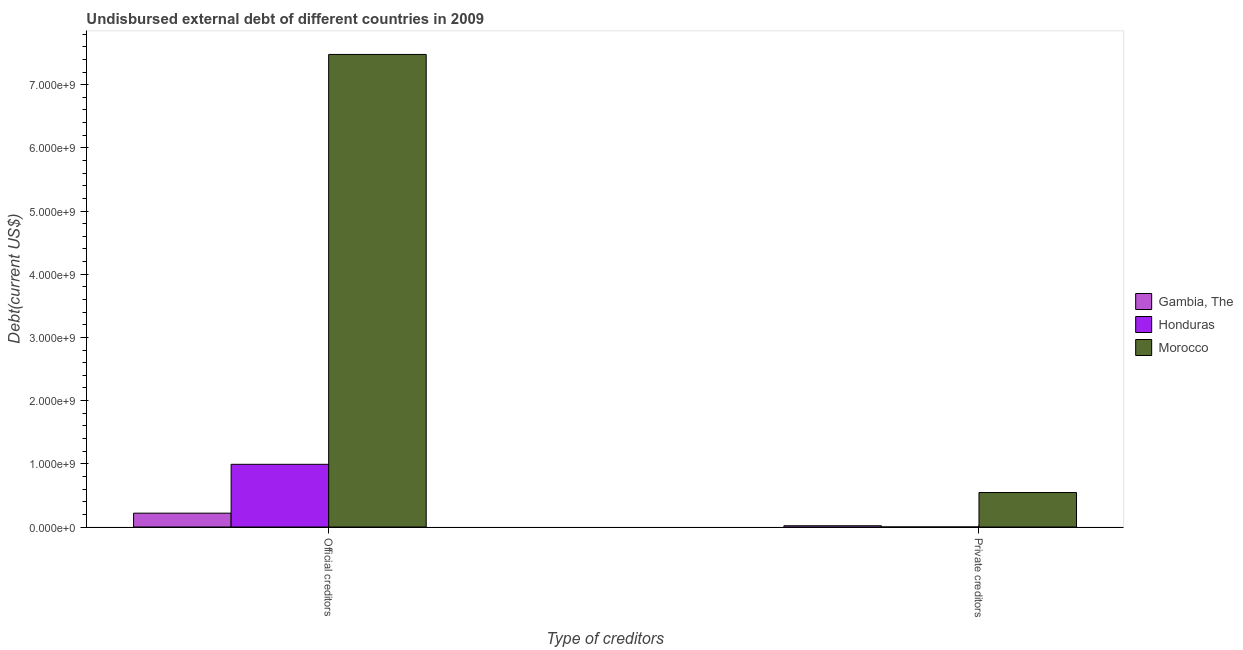How many bars are there on the 1st tick from the left?
Ensure brevity in your answer.  3. How many bars are there on the 2nd tick from the right?
Give a very brief answer. 3. What is the label of the 1st group of bars from the left?
Ensure brevity in your answer.  Official creditors. What is the undisbursed external debt of official creditors in Honduras?
Make the answer very short. 9.92e+08. Across all countries, what is the maximum undisbursed external debt of private creditors?
Keep it short and to the point. 5.46e+08. Across all countries, what is the minimum undisbursed external debt of official creditors?
Your response must be concise. 2.19e+08. In which country was the undisbursed external debt of official creditors maximum?
Ensure brevity in your answer.  Morocco. In which country was the undisbursed external debt of official creditors minimum?
Your answer should be very brief. Gambia, The. What is the total undisbursed external debt of official creditors in the graph?
Offer a very short reply. 8.69e+09. What is the difference between the undisbursed external debt of private creditors in Gambia, The and that in Morocco?
Make the answer very short. -5.26e+08. What is the difference between the undisbursed external debt of private creditors in Gambia, The and the undisbursed external debt of official creditors in Honduras?
Your answer should be very brief. -9.72e+08. What is the average undisbursed external debt of private creditors per country?
Offer a terse response. 1.89e+08. What is the difference between the undisbursed external debt of official creditors and undisbursed external debt of private creditors in Morocco?
Your answer should be compact. 6.93e+09. In how many countries, is the undisbursed external debt of official creditors greater than 4000000000 US$?
Make the answer very short. 1. What is the ratio of the undisbursed external debt of private creditors in Honduras to that in Morocco?
Your response must be concise. 0. In how many countries, is the undisbursed external debt of official creditors greater than the average undisbursed external debt of official creditors taken over all countries?
Offer a very short reply. 1. What does the 1st bar from the left in Official creditors represents?
Provide a succinct answer. Gambia, The. What does the 3rd bar from the right in Official creditors represents?
Offer a very short reply. Gambia, The. Are all the bars in the graph horizontal?
Your response must be concise. No. Does the graph contain any zero values?
Your answer should be very brief. No. Does the graph contain grids?
Offer a terse response. No. How are the legend labels stacked?
Your response must be concise. Vertical. What is the title of the graph?
Provide a succinct answer. Undisbursed external debt of different countries in 2009. What is the label or title of the X-axis?
Give a very brief answer. Type of creditors. What is the label or title of the Y-axis?
Offer a very short reply. Debt(current US$). What is the Debt(current US$) of Gambia, The in Official creditors?
Offer a terse response. 2.19e+08. What is the Debt(current US$) in Honduras in Official creditors?
Your response must be concise. 9.92e+08. What is the Debt(current US$) in Morocco in Official creditors?
Make the answer very short. 7.48e+09. What is the Debt(current US$) of Gambia, The in Private creditors?
Give a very brief answer. 2.00e+07. What is the Debt(current US$) in Honduras in Private creditors?
Your response must be concise. 1.32e+05. What is the Debt(current US$) in Morocco in Private creditors?
Give a very brief answer. 5.46e+08. Across all Type of creditors, what is the maximum Debt(current US$) of Gambia, The?
Your answer should be compact. 2.19e+08. Across all Type of creditors, what is the maximum Debt(current US$) of Honduras?
Keep it short and to the point. 9.92e+08. Across all Type of creditors, what is the maximum Debt(current US$) of Morocco?
Provide a succinct answer. 7.48e+09. Across all Type of creditors, what is the minimum Debt(current US$) in Gambia, The?
Keep it short and to the point. 2.00e+07. Across all Type of creditors, what is the minimum Debt(current US$) of Honduras?
Make the answer very short. 1.32e+05. Across all Type of creditors, what is the minimum Debt(current US$) of Morocco?
Your answer should be compact. 5.46e+08. What is the total Debt(current US$) of Gambia, The in the graph?
Offer a very short reply. 2.39e+08. What is the total Debt(current US$) in Honduras in the graph?
Your response must be concise. 9.92e+08. What is the total Debt(current US$) of Morocco in the graph?
Offer a terse response. 8.02e+09. What is the difference between the Debt(current US$) of Gambia, The in Official creditors and that in Private creditors?
Offer a terse response. 1.99e+08. What is the difference between the Debt(current US$) of Honduras in Official creditors and that in Private creditors?
Give a very brief answer. 9.92e+08. What is the difference between the Debt(current US$) of Morocco in Official creditors and that in Private creditors?
Make the answer very short. 6.93e+09. What is the difference between the Debt(current US$) of Gambia, The in Official creditors and the Debt(current US$) of Honduras in Private creditors?
Provide a succinct answer. 2.19e+08. What is the difference between the Debt(current US$) of Gambia, The in Official creditors and the Debt(current US$) of Morocco in Private creditors?
Provide a succinct answer. -3.27e+08. What is the difference between the Debt(current US$) in Honduras in Official creditors and the Debt(current US$) in Morocco in Private creditors?
Your response must be concise. 4.46e+08. What is the average Debt(current US$) in Gambia, The per Type of creditors?
Give a very brief answer. 1.20e+08. What is the average Debt(current US$) of Honduras per Type of creditors?
Ensure brevity in your answer.  4.96e+08. What is the average Debt(current US$) of Morocco per Type of creditors?
Your answer should be compact. 4.01e+09. What is the difference between the Debt(current US$) in Gambia, The and Debt(current US$) in Honduras in Official creditors?
Your answer should be compact. -7.73e+08. What is the difference between the Debt(current US$) in Gambia, The and Debt(current US$) in Morocco in Official creditors?
Make the answer very short. -7.26e+09. What is the difference between the Debt(current US$) in Honduras and Debt(current US$) in Morocco in Official creditors?
Offer a terse response. -6.49e+09. What is the difference between the Debt(current US$) of Gambia, The and Debt(current US$) of Honduras in Private creditors?
Your answer should be very brief. 1.99e+07. What is the difference between the Debt(current US$) in Gambia, The and Debt(current US$) in Morocco in Private creditors?
Your answer should be compact. -5.26e+08. What is the difference between the Debt(current US$) in Honduras and Debt(current US$) in Morocco in Private creditors?
Give a very brief answer. -5.46e+08. What is the ratio of the Debt(current US$) of Gambia, The in Official creditors to that in Private creditors?
Ensure brevity in your answer.  10.96. What is the ratio of the Debt(current US$) of Honduras in Official creditors to that in Private creditors?
Make the answer very short. 7517.68. What is the ratio of the Debt(current US$) in Morocco in Official creditors to that in Private creditors?
Your response must be concise. 13.7. What is the difference between the highest and the second highest Debt(current US$) of Gambia, The?
Provide a short and direct response. 1.99e+08. What is the difference between the highest and the second highest Debt(current US$) in Honduras?
Provide a succinct answer. 9.92e+08. What is the difference between the highest and the second highest Debt(current US$) in Morocco?
Keep it short and to the point. 6.93e+09. What is the difference between the highest and the lowest Debt(current US$) in Gambia, The?
Your response must be concise. 1.99e+08. What is the difference between the highest and the lowest Debt(current US$) of Honduras?
Offer a terse response. 9.92e+08. What is the difference between the highest and the lowest Debt(current US$) in Morocco?
Provide a succinct answer. 6.93e+09. 